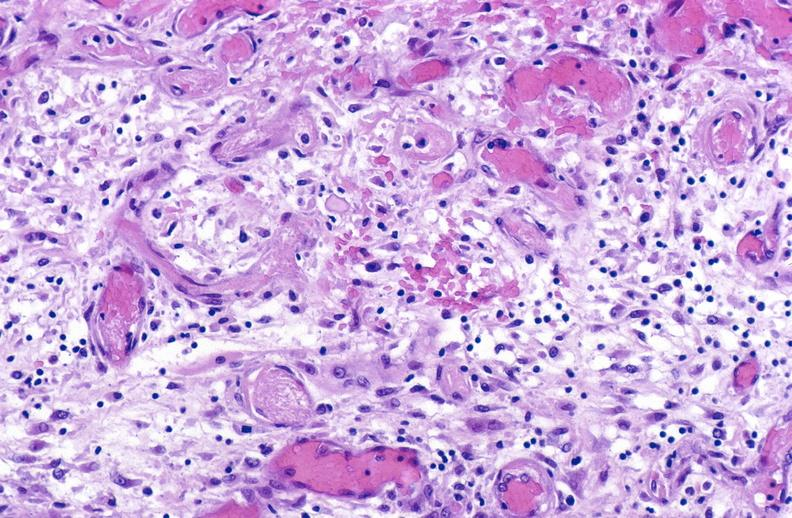does this image show tracheotomy site, granulation tissue?
Answer the question using a single word or phrase. Yes 